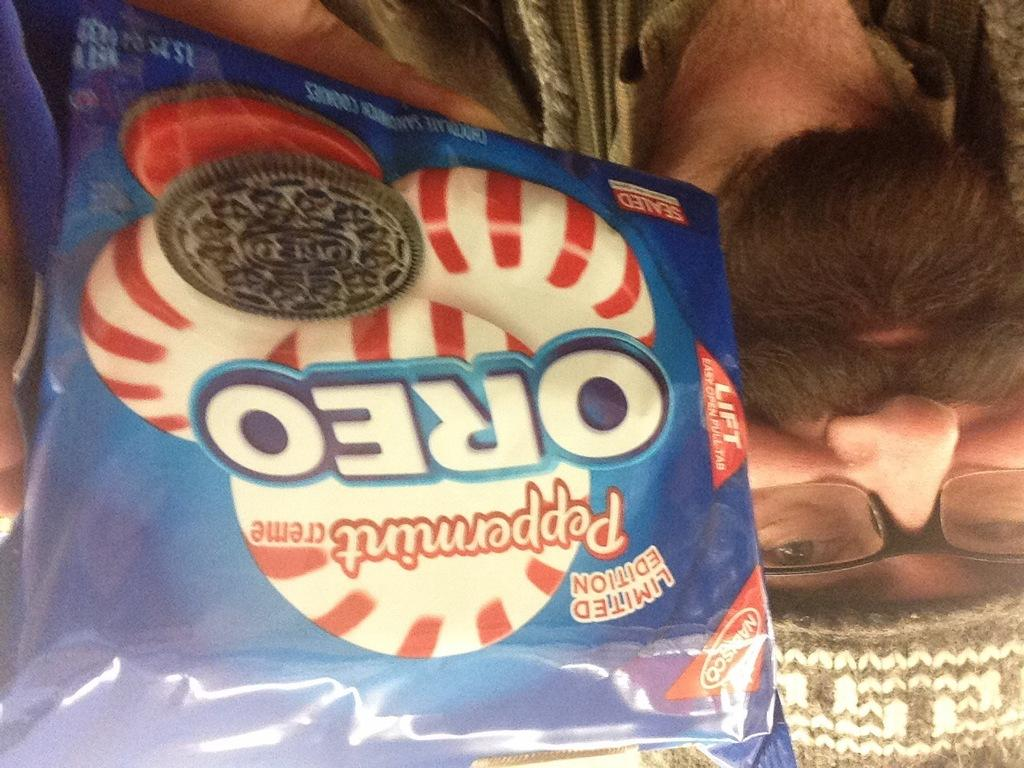What is the person holding in the image? The person is holding a biscuit packet in the image. What brand of biscuits is in the packet? The biscuit packet has the word "OREO" on it. What symbol is on the biscuit packet? The biscuit packet has a biscuit symbol on it. Can you describe the person holding the biscuit packet? The man holding the biscuit packet has a beard. How many girls are visible in the image holding a tent? There are no girls or tents present in the image; it features a person holding a biscuit packet. 